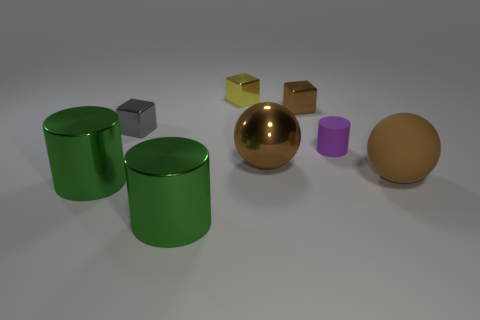Subtract all yellow metal blocks. How many blocks are left? 2 Subtract 1 blocks. How many blocks are left? 2 Add 1 big green cylinders. How many objects exist? 9 Subtract all blocks. How many objects are left? 5 Subtract all large cylinders. Subtract all brown rubber things. How many objects are left? 5 Add 7 purple cylinders. How many purple cylinders are left? 8 Add 2 small gray things. How many small gray things exist? 3 Subtract 0 green blocks. How many objects are left? 8 